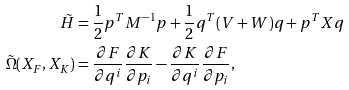<formula> <loc_0><loc_0><loc_500><loc_500>\tilde { H } & = \frac { 1 } { 2 } { p } ^ { T } M ^ { - 1 } { p } + \frac { 1 } { 2 } { q } ^ { T } ( V + W ) { q } + { p } ^ { T } X { q } \\ \tilde { \Omega } ( X _ { F } , X _ { K } ) & = \frac { \partial F } { \partial q ^ { i } } \frac { \partial K } { \partial p _ { i } } - \frac { \partial K } { \partial q ^ { i } } \frac { \partial F } { \partial p _ { i } } ,</formula> 